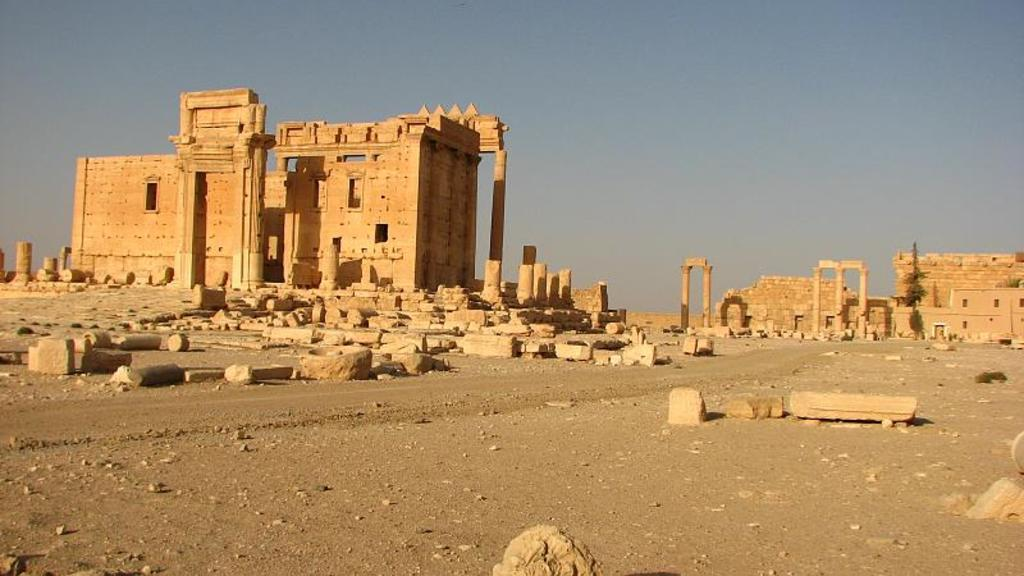What type of structures can be seen in the image? There are forts in the image. What architectural elements are present in the forts? There are pillars in the image. What can be seen beneath the forts and pillars? The ground is visible in the image. Are there any objects placed on the ground? Yes, there are objects on the ground. What is visible above the forts and pillars? The sky is visible in the image. What type of disgust can be seen on the faces of the people in the image? There are no people present in the image, so it is not possible to determine their emotions or expressions. 